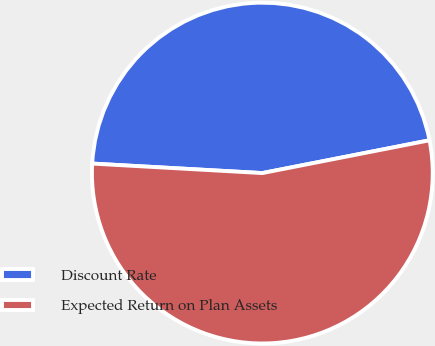Convert chart to OTSL. <chart><loc_0><loc_0><loc_500><loc_500><pie_chart><fcel>Discount Rate<fcel>Expected Return on Plan Assets<nl><fcel>46.03%<fcel>53.97%<nl></chart> 